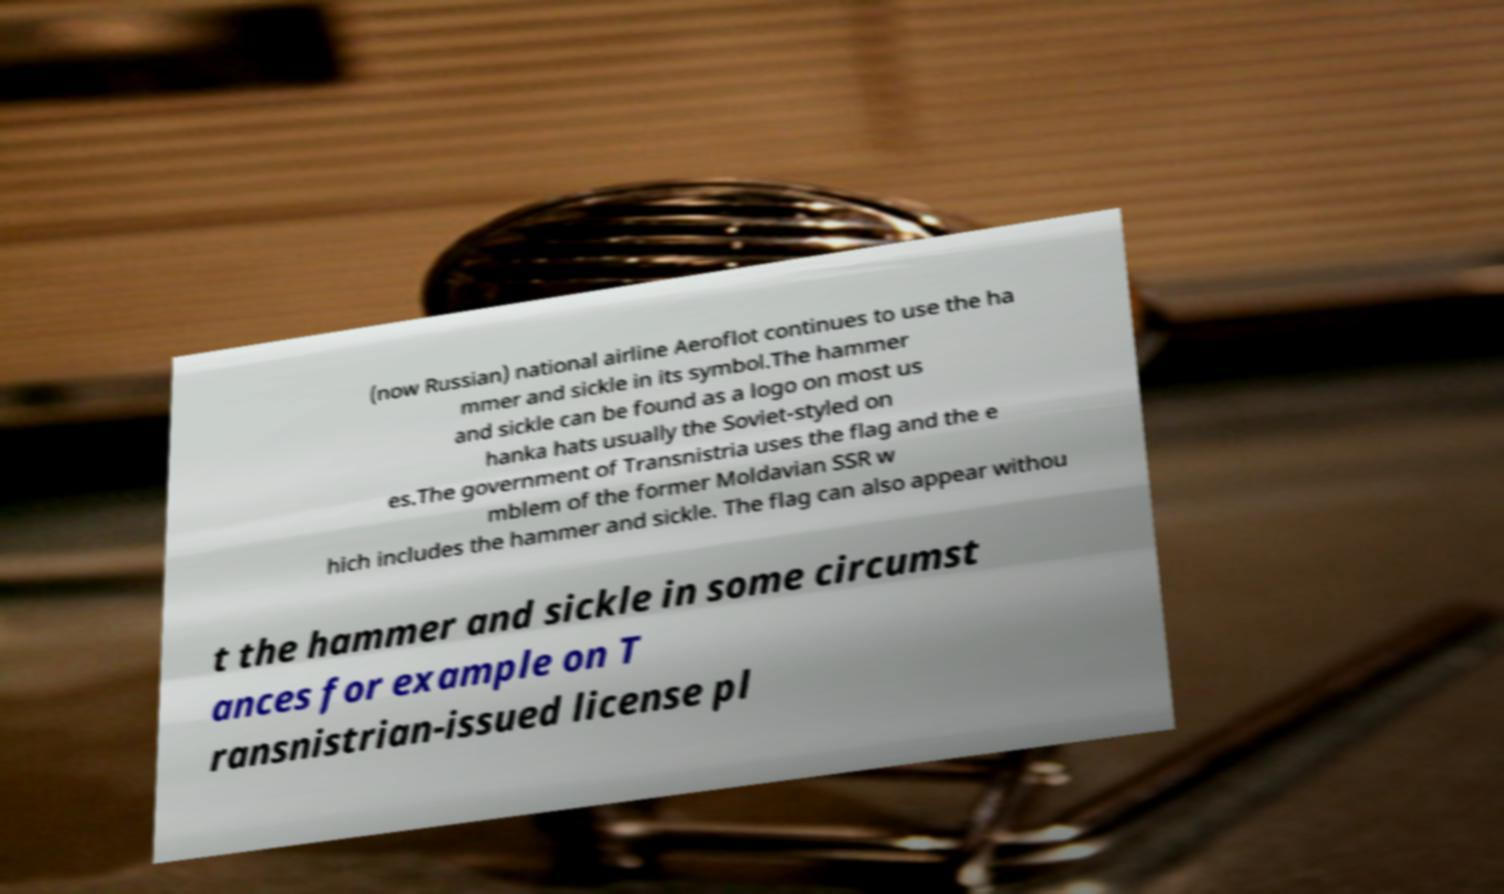There's text embedded in this image that I need extracted. Can you transcribe it verbatim? (now Russian) national airline Aeroflot continues to use the ha mmer and sickle in its symbol.The hammer and sickle can be found as a logo on most us hanka hats usually the Soviet-styled on es.The government of Transnistria uses the flag and the e mblem of the former Moldavian SSR w hich includes the hammer and sickle. The flag can also appear withou t the hammer and sickle in some circumst ances for example on T ransnistrian-issued license pl 